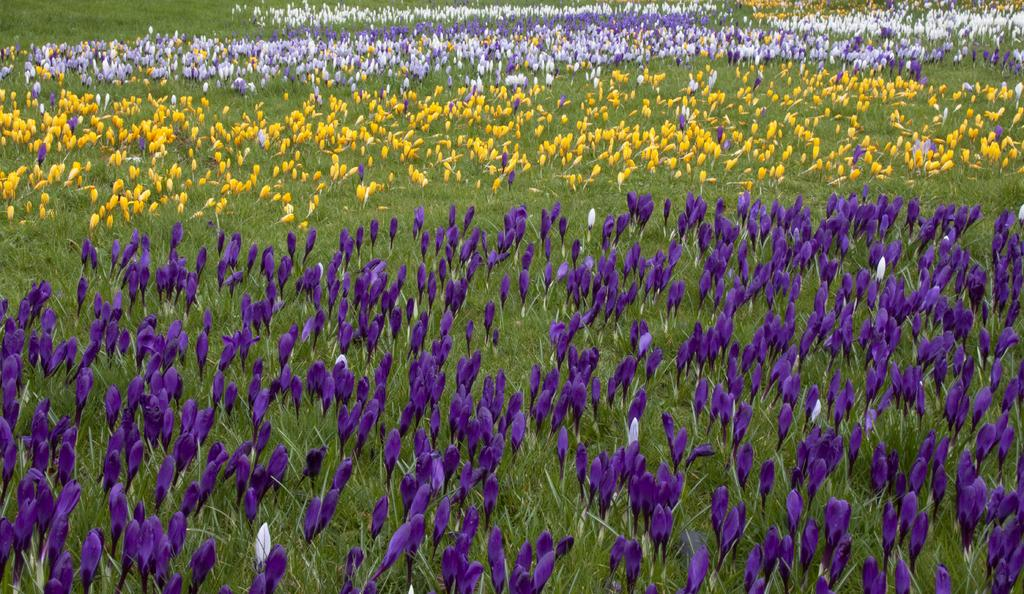What type of surface is visible in the image? There is a grass surface in the image. What type of plants can be seen on the grass surface? There are grass plants in the image. What colors of flowers are present in the image? There are blue, white, yellow, and violet flowers in the image. What type of pan is being used to move the flowers in the image? There is no pan present in the image, and the flowers are not being moved. 